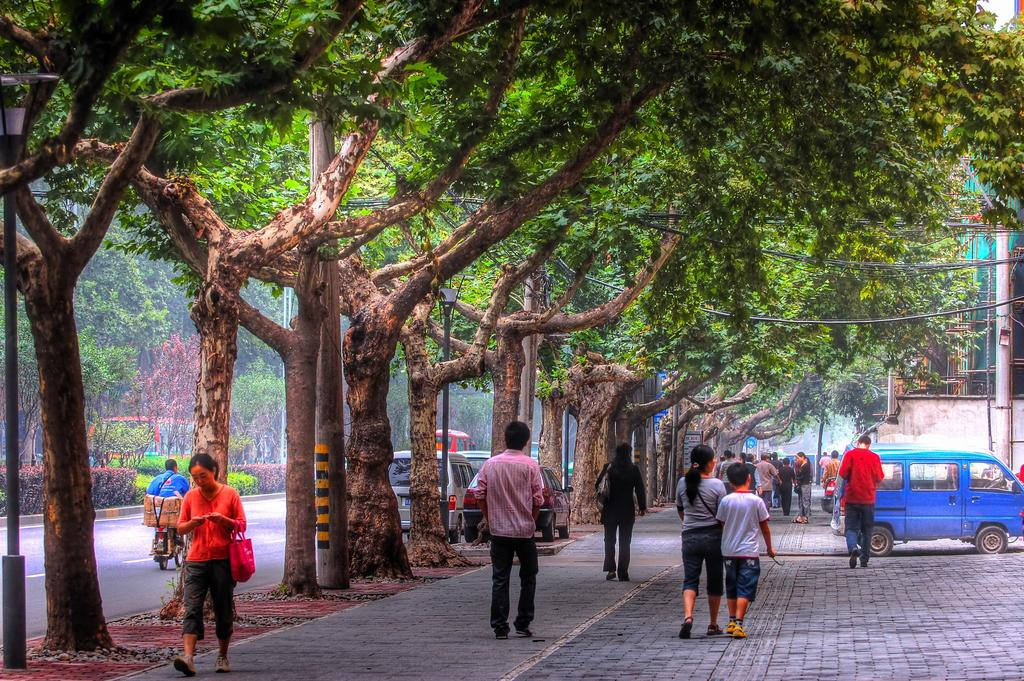How many people are in the image? There are people in the image, but the exact number is not specified. What are some of the people doing in the image? Some people are walking, and there is a person riding a bike on the road. What can be seen in the background of the image? In the background, there are plants and trees. What type of structures are present in the image? There are poles and lights in the image. What else can be seen in the image besides people and structures? There are vehicles in the image. How many eyes does the person riding the bike have in the image? The number of eyes the person riding the bike has is not visible or mentioned in the image. What type of ray is emitted from the lights in the image? There is no mention of any rays being emitted from the lights in the image. 